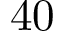Convert formula to latex. <formula><loc_0><loc_0><loc_500><loc_500>4 0</formula> 